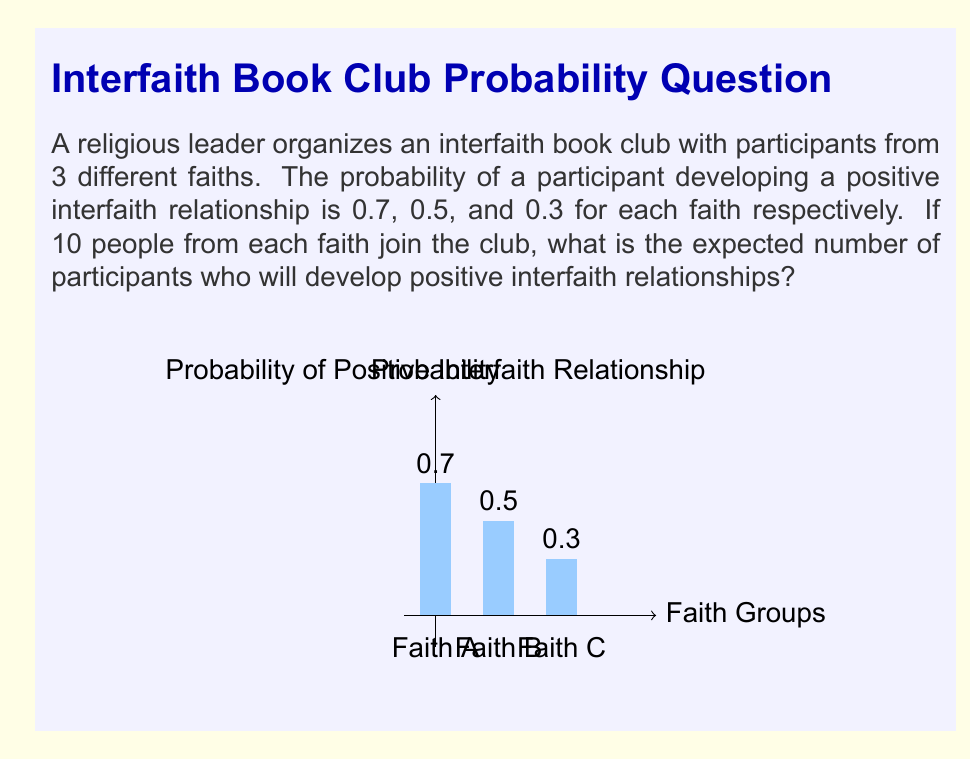Can you answer this question? Let's approach this step-by-step:

1) First, we need to calculate the expected number of participants from each faith who will develop positive interfaith relationships.

2) For Faith A:
   Expected number = Number of participants × Probability
   $E_A = 10 \times 0.7 = 7$

3) For Faith B:
   $E_B = 10 \times 0.5 = 5$

4) For Faith C:
   $E_C = 10 \times 0.3 = 3$

5) The total expected number is the sum of these individual expectations:

   $E_{total} = E_A + E_B + E_C$

6) Substituting the values:

   $E_{total} = 7 + 5 + 3 = 15$

Therefore, the expected number of participants who will develop positive interfaith relationships is 15.
Answer: 15 participants 